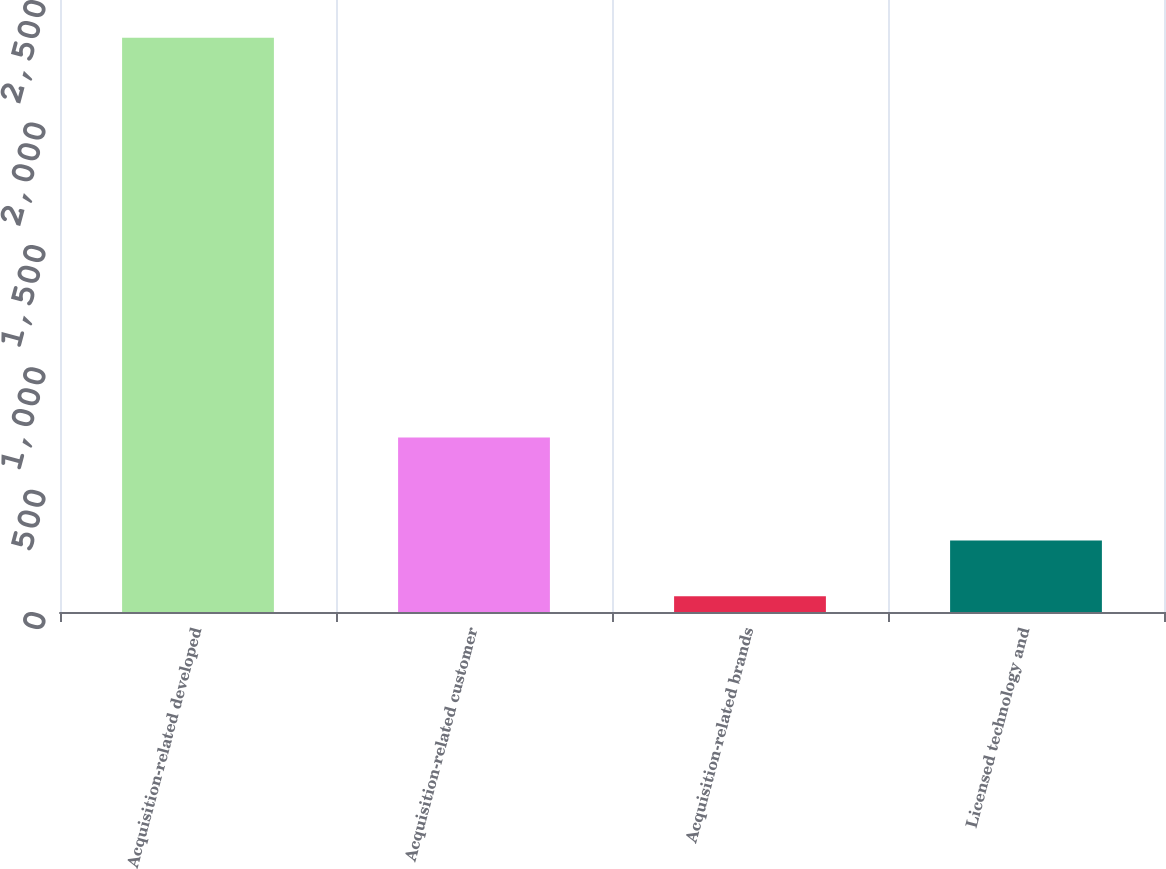Convert chart. <chart><loc_0><loc_0><loc_500><loc_500><bar_chart><fcel>Acquisition-related developed<fcel>Acquisition-related customer<fcel>Acquisition-related brands<fcel>Licensed technology and<nl><fcel>2346<fcel>713<fcel>64<fcel>292.2<nl></chart> 